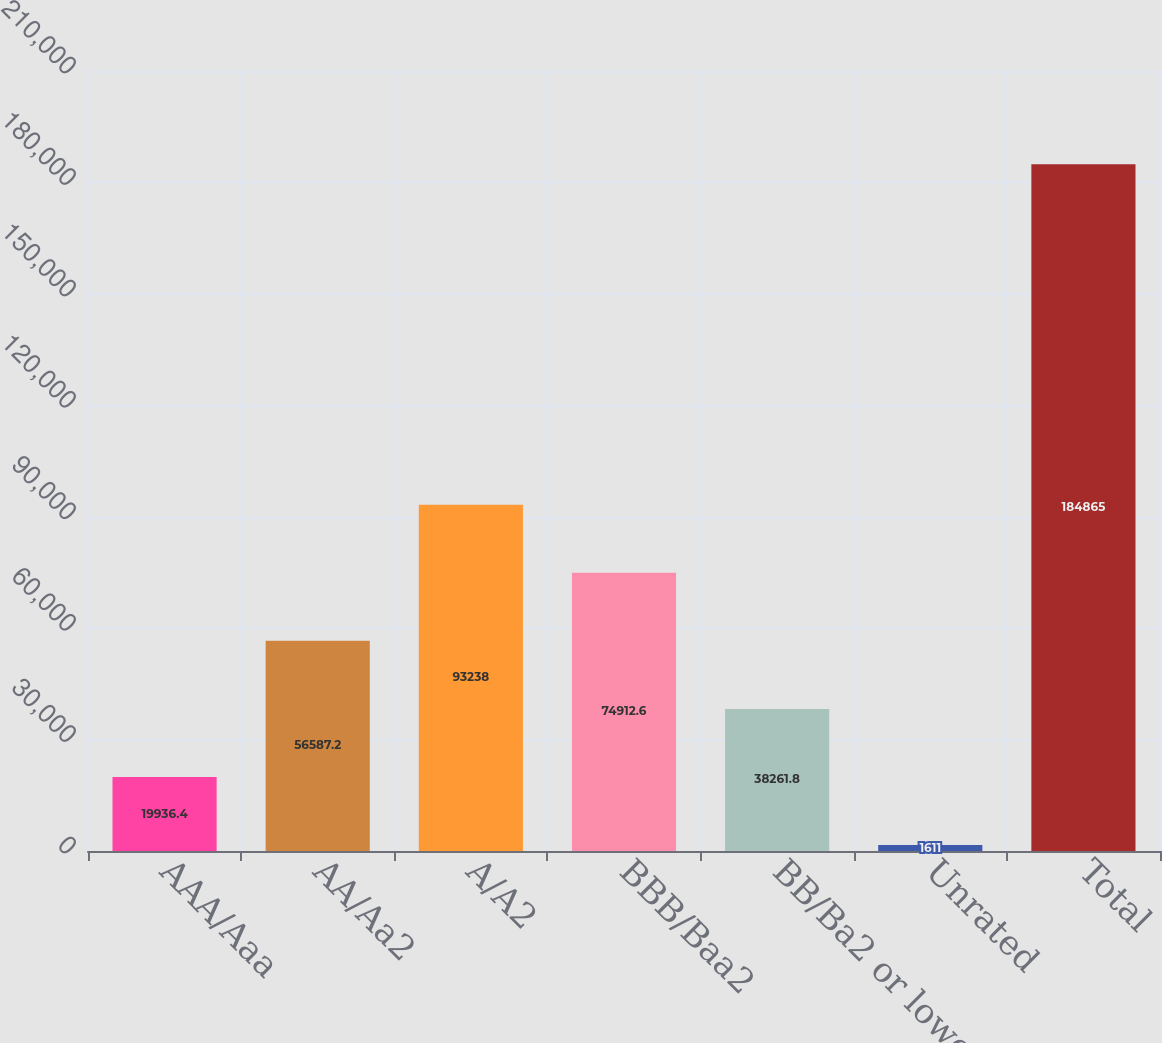Convert chart to OTSL. <chart><loc_0><loc_0><loc_500><loc_500><bar_chart><fcel>AAA/Aaa<fcel>AA/Aa2<fcel>A/A2<fcel>BBB/Baa2<fcel>BB/Ba2 or lower<fcel>Unrated<fcel>Total<nl><fcel>19936.4<fcel>56587.2<fcel>93238<fcel>74912.6<fcel>38261.8<fcel>1611<fcel>184865<nl></chart> 